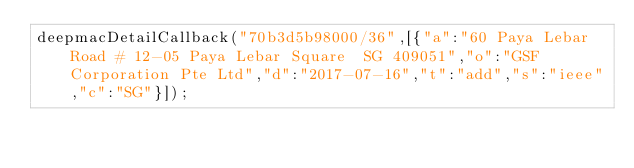<code> <loc_0><loc_0><loc_500><loc_500><_JavaScript_>deepmacDetailCallback("70b3d5b98000/36",[{"a":"60 Paya Lebar Road # 12-05 Paya Lebar Square  SG 409051","o":"GSF Corporation Pte Ltd","d":"2017-07-16","t":"add","s":"ieee","c":"SG"}]);
</code> 